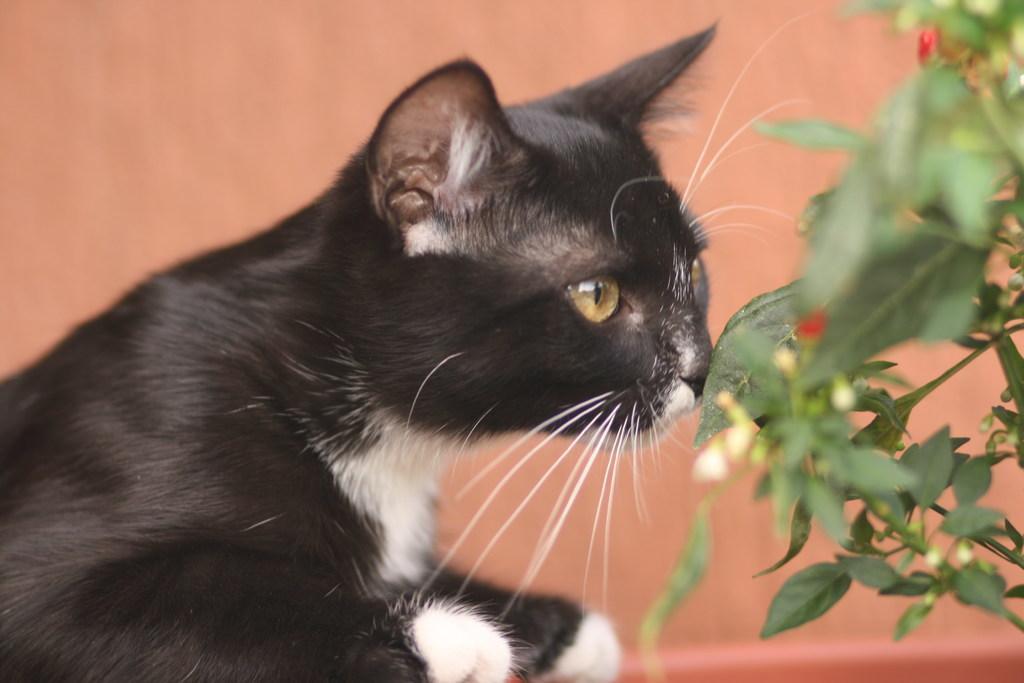Could you give a brief overview of what you see in this image? In this picture there is a cat and we can see leaves. In the background of the image it is peach color. 